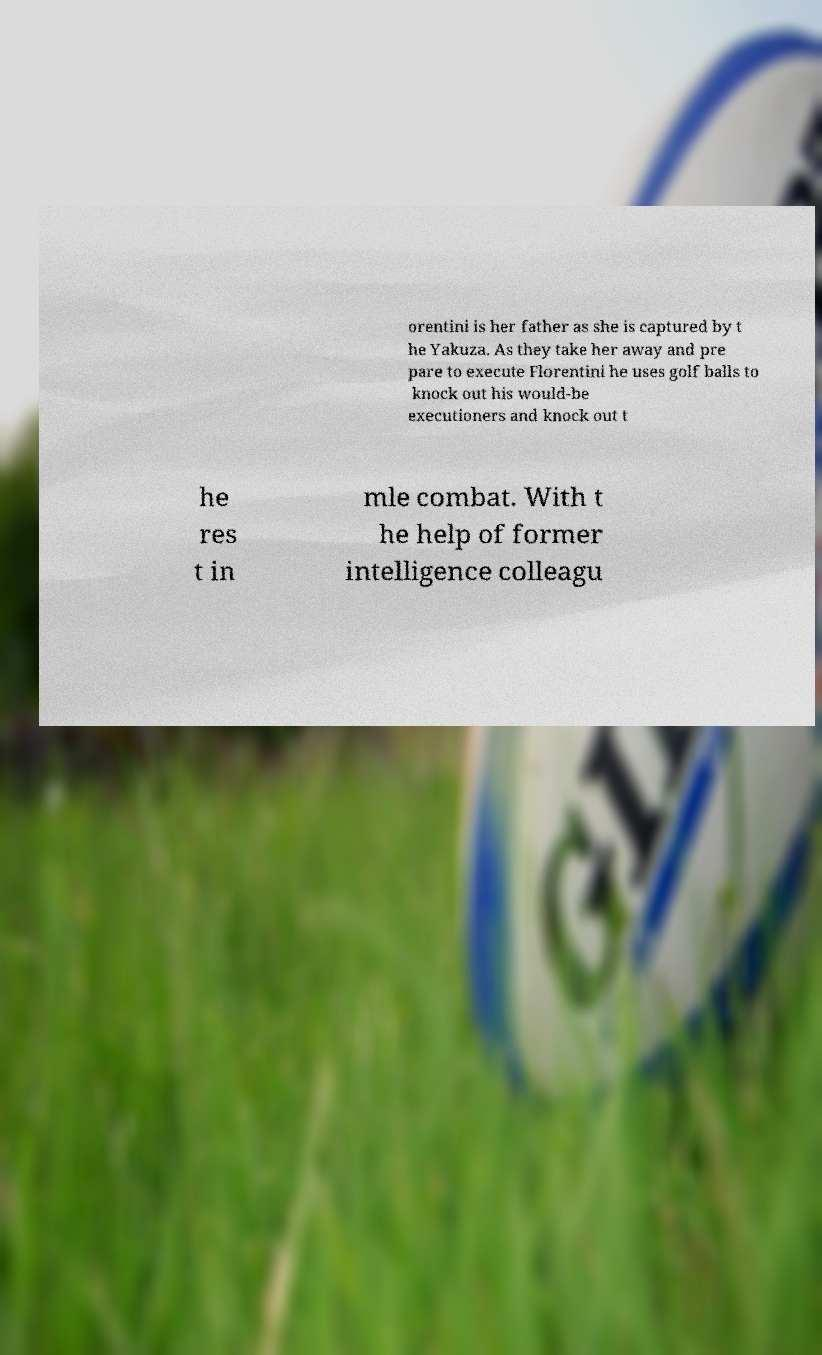Could you assist in decoding the text presented in this image and type it out clearly? orentini is her father as she is captured by t he Yakuza. As they take her away and pre pare to execute Florentini he uses golf balls to knock out his would-be executioners and knock out t he res t in mle combat. With t he help of former intelligence colleagu 